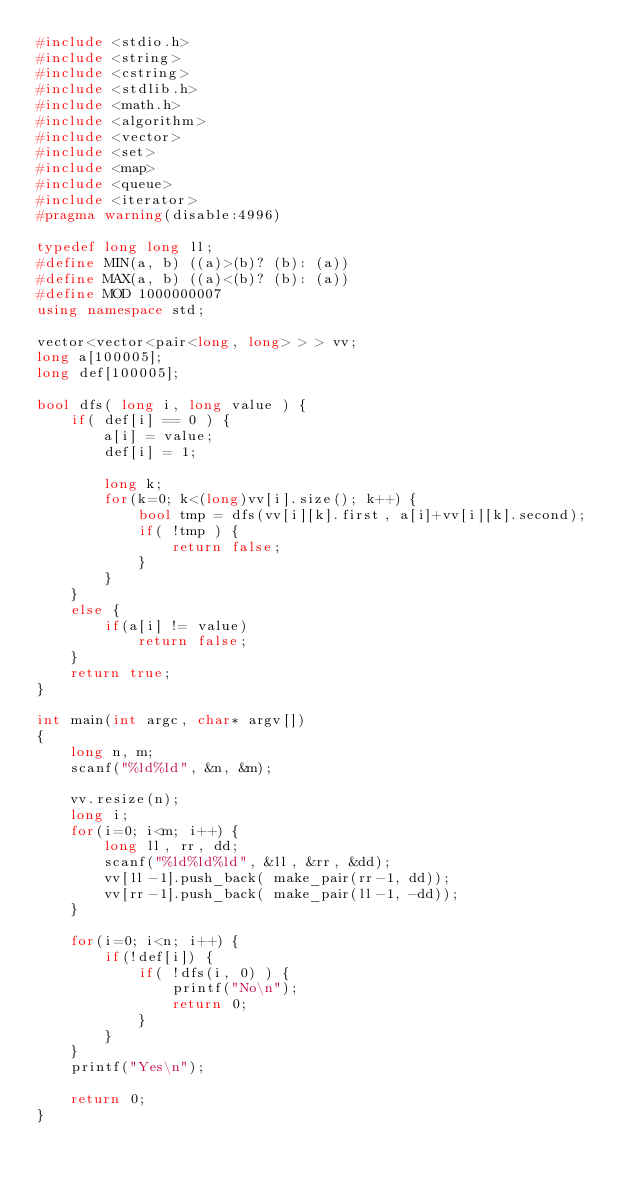<code> <loc_0><loc_0><loc_500><loc_500><_C++_>#include <stdio.h>
#include <string>
#include <cstring>
#include <stdlib.h>
#include <math.h>
#include <algorithm>
#include <vector>
#include <set>
#include <map>
#include <queue>
#include <iterator>
#pragma warning(disable:4996)
 
typedef long long ll;
#define MIN(a, b) ((a)>(b)? (b): (a))
#define MAX(a, b) ((a)<(b)? (b): (a))
#define MOD 1000000007
using namespace std;

vector<vector<pair<long, long> > > vv;
long a[100005];
long def[100005];

bool dfs( long i, long value ) {
    if( def[i] == 0 ) {
        a[i] = value;
        def[i] = 1;

        long k;
        for(k=0; k<(long)vv[i].size(); k++) {
            bool tmp = dfs(vv[i][k].first, a[i]+vv[i][k].second);
            if( !tmp ) {
                return false;
            }
        }
    }
    else {
        if(a[i] != value)
            return false;
    }
    return true;
}

int main(int argc, char* argv[])
{
    long n, m;
    scanf("%ld%ld", &n, &m);

    vv.resize(n);
    long i;
    for(i=0; i<m; i++) {
        long ll, rr, dd;
        scanf("%ld%ld%ld", &ll, &rr, &dd);
        vv[ll-1].push_back( make_pair(rr-1, dd));
        vv[rr-1].push_back( make_pair(ll-1, -dd));
    }

    for(i=0; i<n; i++) {
        if(!def[i]) {
            if( !dfs(i, 0) ) {
                printf("No\n");
                return 0;
            }
        }
    }
    printf("Yes\n");

    return 0;
}
</code> 